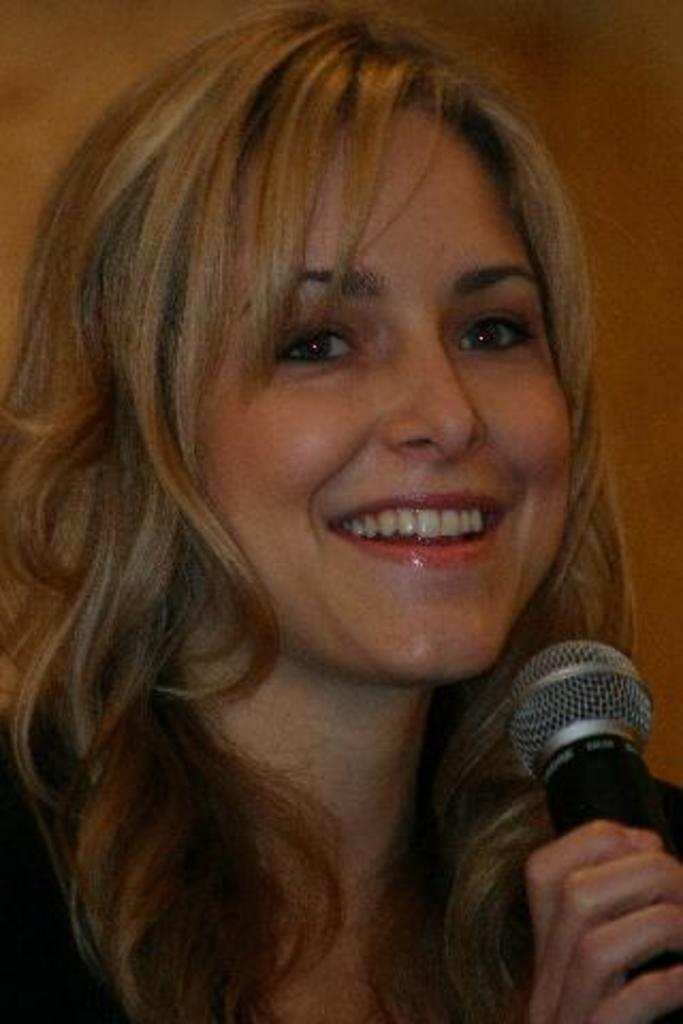What is the main subject of the image? The main subject of the image is a woman. What is the woman doing in the image? The woman is looking somewhere and smiling. What object is the woman holding in her hand? The woman is holding a microphone in her hand. What type of attraction can be seen in the background of the image? There is no attraction visible in the background of the image. How many creatures are present in the image? There are no creatures present in the image; it features a woman holding a microphone. 